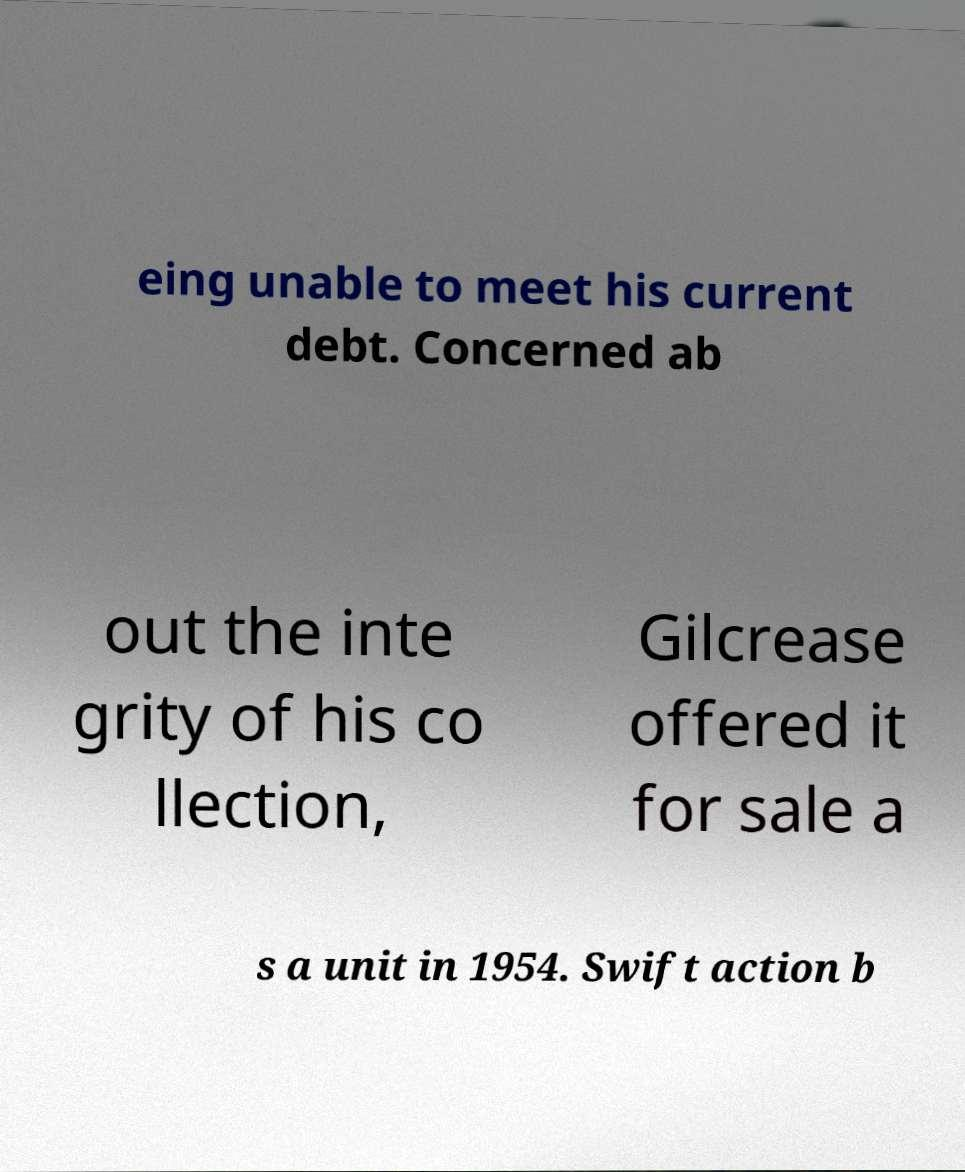Please read and relay the text visible in this image. What does it say? eing unable to meet his current debt. Concerned ab out the inte grity of his co llection, Gilcrease offered it for sale a s a unit in 1954. Swift action b 